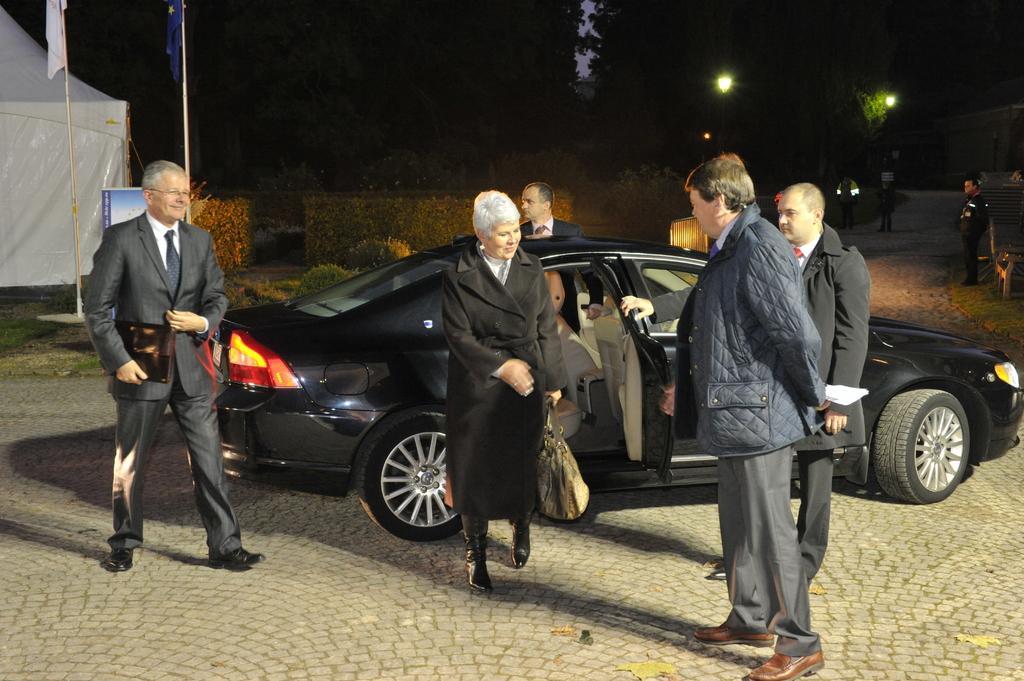Please provide a concise description of this image. In this image, we can see few people. Few are walking and standing. Few are holding some objects. Here we can see a woman and man are smiling. There is a black car on the platform. Background we can see tent, poles with flags, lights, plants. Few people are here. 